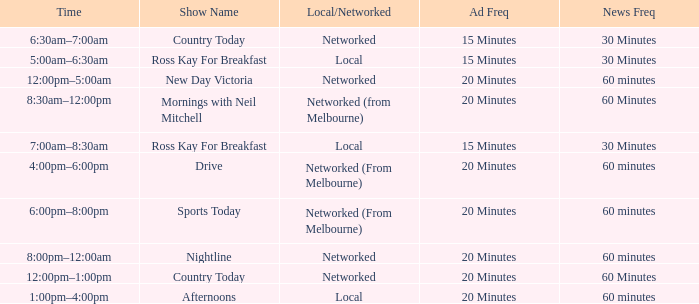What News Freq has a Time of 1:00pm–4:00pm? 60 minutes. 